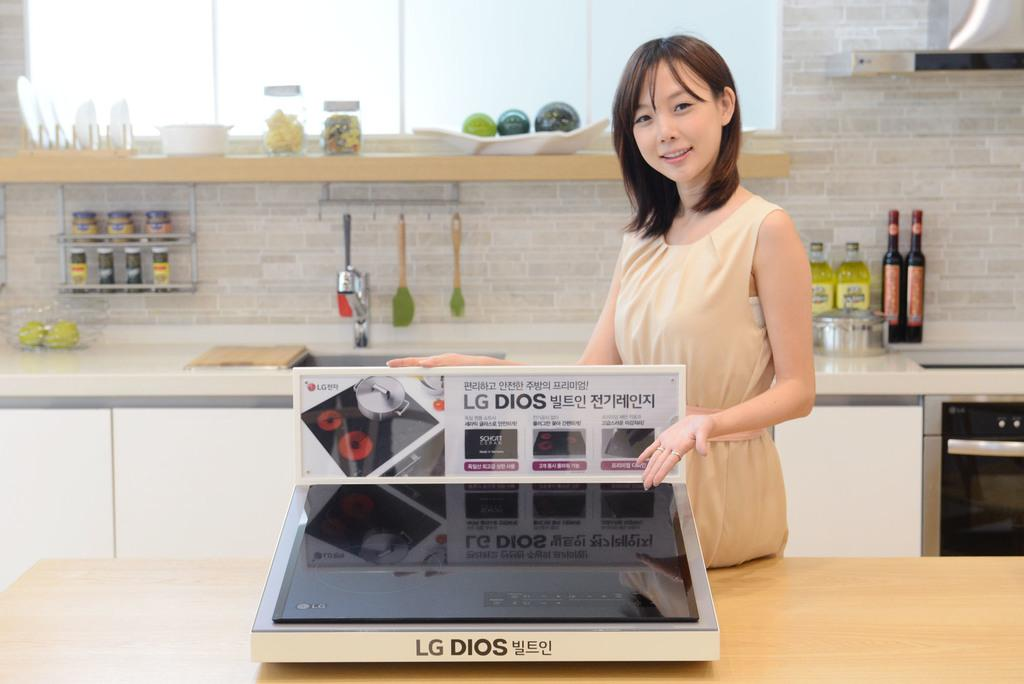Who is present in the image? There is a woman in the image. Where is the woman located in the image? The woman is standing on the right side. What is the woman holding or showing in the image? The woman is holding or showing an electronic device. What can be seen in the background of the image? There are oil bottles and a sink in the background of the image. What type of circle can be seen on the electronic device the woman is holding? There is no circle visible on the electronic device the woman is holding in the image. 